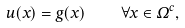<formula> <loc_0><loc_0><loc_500><loc_500>u ( x ) = g ( x ) \quad \forall x \in \Omega ^ { c } ,</formula> 